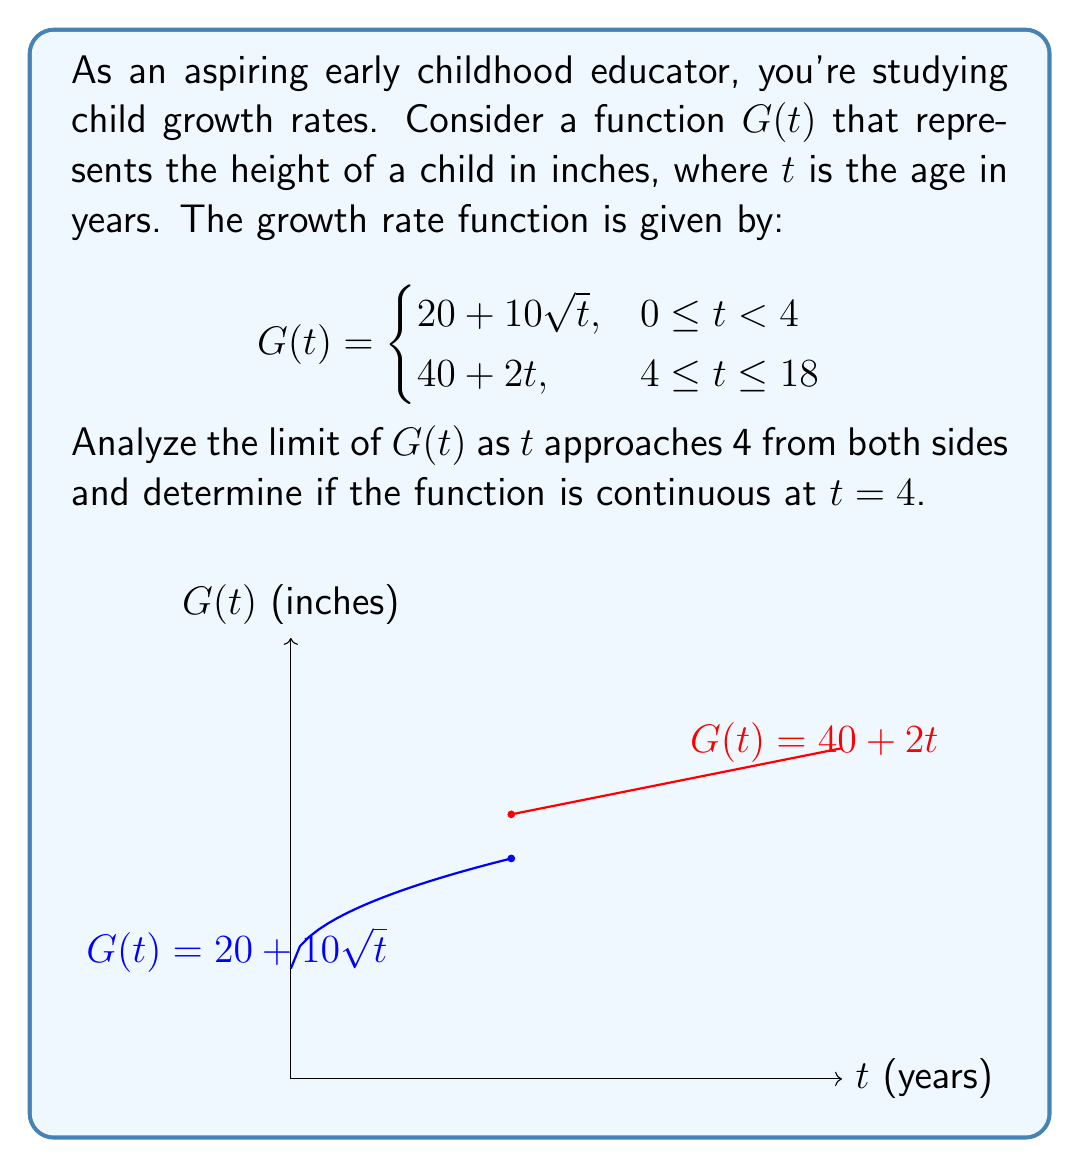What is the answer to this math problem? Let's approach this step-by-step:

1) First, we need to find the limit of $G(t)$ as $t$ approaches 4 from the left:
   $$\lim_{t \to 4^-} G(t) = \lim_{t \to 4^-} (20 + 10\sqrt{t}) = 20 + 10\sqrt{4} = 20 + 20 = 40$$

2) Now, let's find the limit of $G(t)$ as $t$ approaches 4 from the right:
   $$\lim_{t \to 4^+} G(t) = \lim_{t \to 4^+} (40 + 2t) = 40 + 2(4) = 48$$

3) We can see that these limits are not equal:
   $$\lim_{t \to 4^-} G(t) \neq \lim_{t \to 4^+} G(t)$$

4) For a function to be continuous at a point, three conditions must be met:
   a) The function must be defined at that point
   b) The limit of the function as we approach the point from both sides must exist
   c) The limit must equal the function's value at that point

5) In this case, condition (b) is not met because the left-hand and right-hand limits are not equal.

6) We can also check the actual value of $G(4)$:
   $$G(4) = 40 + 2(4) = 48$$

   This matches the right-hand limit but not the left-hand limit.

Therefore, $G(t)$ is not continuous at $t = 4$. There is a jump discontinuity at this point, representing a sudden change in the growth rate model at age 4.
Answer: $\lim_{t \to 4^-} G(t) = 40$, $\lim_{t \to 4^+} G(t) = 48$. $G(t)$ is discontinuous at $t = 4$. 